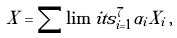<formula> <loc_0><loc_0><loc_500><loc_500>X = \sum \lim i t s _ { i = 1 } ^ { 7 } \alpha _ { i } X _ { i } \, ,</formula> 